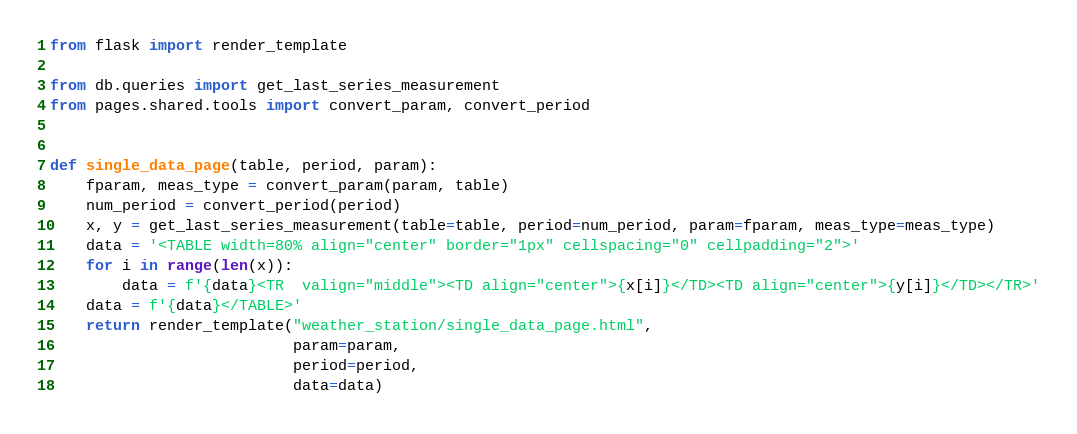<code> <loc_0><loc_0><loc_500><loc_500><_Python_>from flask import render_template

from db.queries import get_last_series_measurement
from pages.shared.tools import convert_param, convert_period


def single_data_page(table, period, param):
    fparam, meas_type = convert_param(param, table)
    num_period = convert_period(period)
    x, y = get_last_series_measurement(table=table, period=num_period, param=fparam, meas_type=meas_type)
    data = '<TABLE width=80% align="center" border="1px" cellspacing="0" cellpadding="2">'
    for i in range(len(x)):
        data = f'{data}<TR  valign="middle"><TD align="center">{x[i]}</TD><TD align="center">{y[i]}</TD></TR>'
    data = f'{data}</TABLE>'
    return render_template("weather_station/single_data_page.html",
                           param=param,
                           period=period,
                           data=data)
</code> 